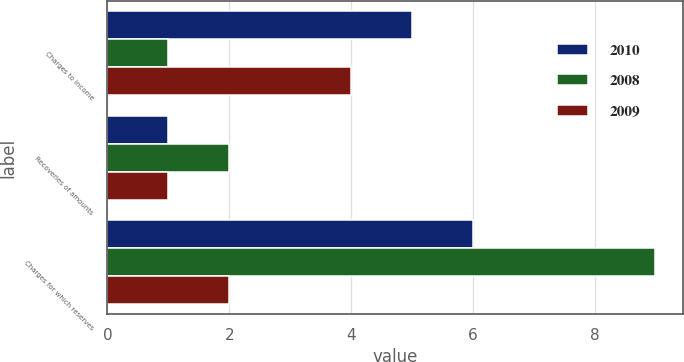Convert chart to OTSL. <chart><loc_0><loc_0><loc_500><loc_500><stacked_bar_chart><ecel><fcel>Charges to income<fcel>Recoveries of amounts<fcel>Charges for which reserves<nl><fcel>2010<fcel>5<fcel>1<fcel>6<nl><fcel>2008<fcel>1<fcel>2<fcel>9<nl><fcel>2009<fcel>4<fcel>1<fcel>2<nl></chart> 